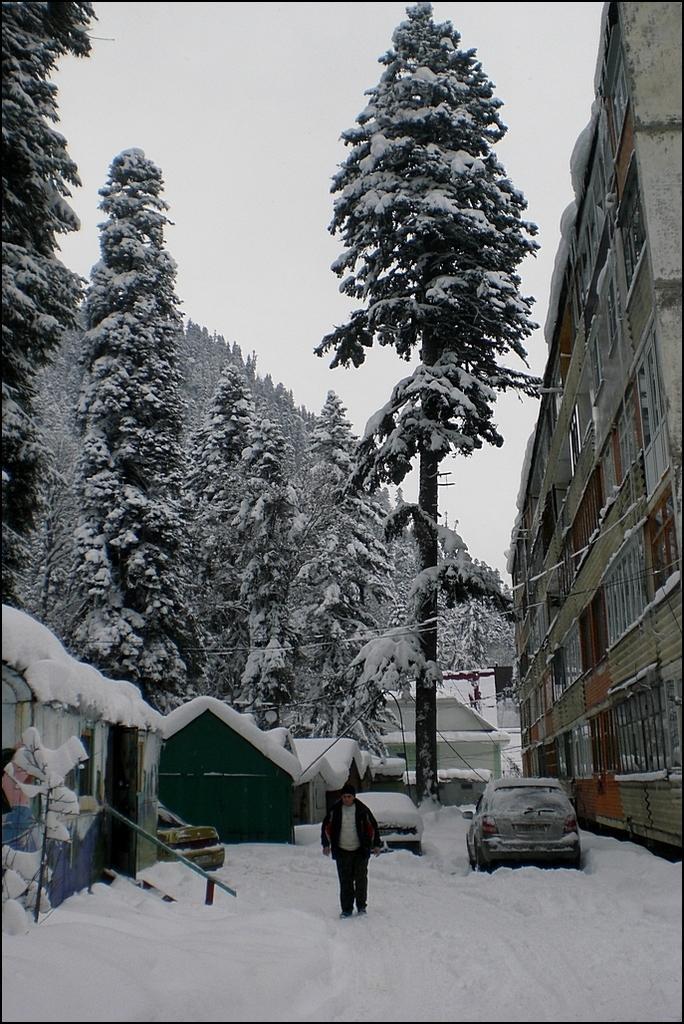Please provide a concise description of this image. This picture is clicked outside. In the center there is a person walking on the ground, the ground is covered with a lot of snow. In the center we can see the two vehicles and the houses. On the right there is a building. In the background there is a sky and the trees. 